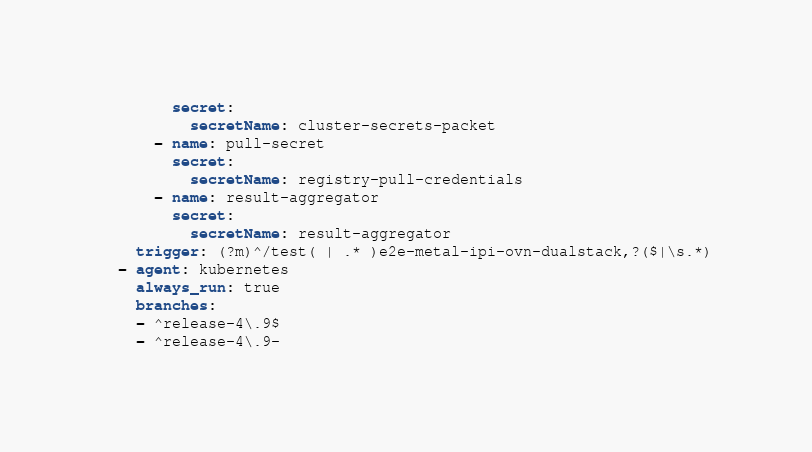<code> <loc_0><loc_0><loc_500><loc_500><_YAML_>        secret:
          secretName: cluster-secrets-packet
      - name: pull-secret
        secret:
          secretName: registry-pull-credentials
      - name: result-aggregator
        secret:
          secretName: result-aggregator
    trigger: (?m)^/test( | .* )e2e-metal-ipi-ovn-dualstack,?($|\s.*)
  - agent: kubernetes
    always_run: true
    branches:
    - ^release-4\.9$
    - ^release-4\.9-</code> 